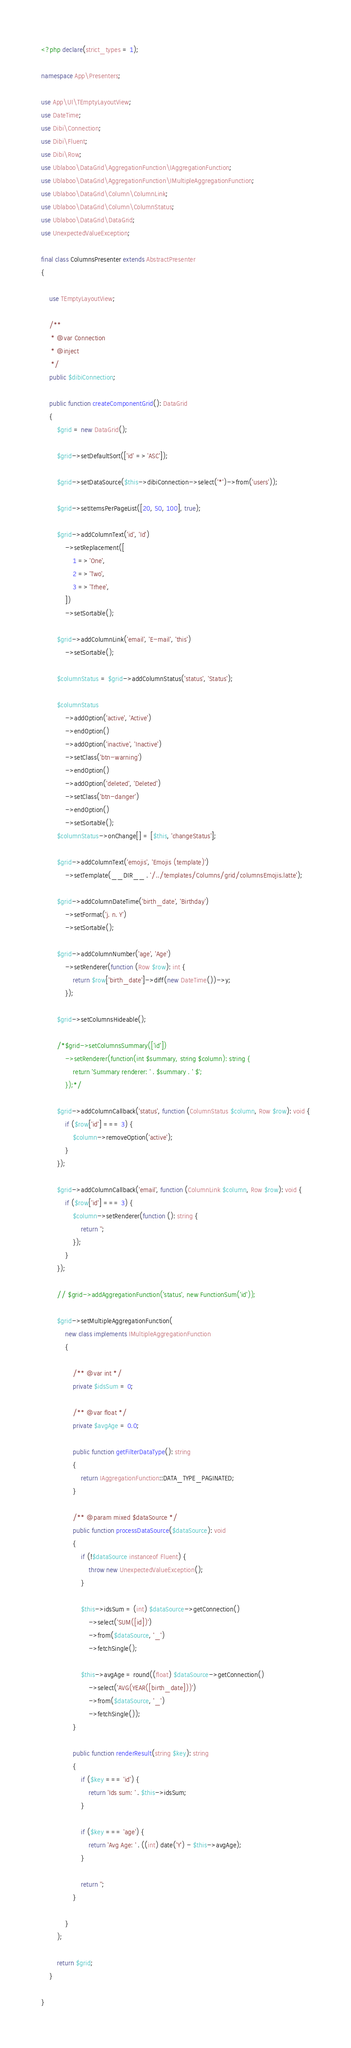Convert code to text. <code><loc_0><loc_0><loc_500><loc_500><_PHP_><?php declare(strict_types = 1);

namespace App\Presenters;

use App\UI\TEmptyLayoutView;
use DateTime;
use Dibi\Connection;
use Dibi\Fluent;
use Dibi\Row;
use Ublaboo\DataGrid\AggregationFunction\IAggregationFunction;
use Ublaboo\DataGrid\AggregationFunction\IMultipleAggregationFunction;
use Ublaboo\DataGrid\Column\ColumnLink;
use Ublaboo\DataGrid\Column\ColumnStatus;
use Ublaboo\DataGrid\DataGrid;
use UnexpectedValueException;

final class ColumnsPresenter extends AbstractPresenter
{

	use TEmptyLayoutView;

	/**
	 * @var Connection
	 * @inject
	 */
	public $dibiConnection;

	public function createComponentGrid(): DataGrid
	{
		$grid = new DataGrid();

		$grid->setDefaultSort(['id' => 'ASC']);

		$grid->setDataSource($this->dibiConnection->select('*')->from('users'));

		$grid->setItemsPerPageList([20, 50, 100], true);

		$grid->addColumnText('id', 'Id')
			->setReplacement([
				1 => 'One',
				2 => 'Two',
				3 => 'Trhee',
			])
			->setSortable();

		$grid->addColumnLink('email', 'E-mail', 'this')
			->setSortable();

		$columnStatus = $grid->addColumnStatus('status', 'Status');

		$columnStatus
			->addOption('active', 'Active')
			->endOption()
			->addOption('inactive', 'Inactive')
			->setClass('btn-warning')
			->endOption()
			->addOption('deleted', 'Deleted')
			->setClass('btn-danger')
			->endOption()
			->setSortable();
		$columnStatus->onChange[] = [$this, 'changeStatus'];

		$grid->addColumnText('emojis', 'Emojis (template)')
			->setTemplate(__DIR__ . '/../templates/Columns/grid/columnsEmojis.latte');

		$grid->addColumnDateTime('birth_date', 'Birthday')
			->setFormat('j. n. Y')
			->setSortable();

		$grid->addColumnNumber('age', 'Age')
			->setRenderer(function (Row $row): int {
				return $row['birth_date']->diff(new DateTime())->y;
			});

		$grid->setColumnsHideable();

		/*$grid->setColumnsSummary(['id'])
			->setRenderer(function(int $summary, string $column): string {
				return 'Summary renderer: ' . $summary . ' $';
			});*/

		$grid->addColumnCallback('status', function (ColumnStatus $column, Row $row): void {
			if ($row['id'] === 3) {
				$column->removeOption('active');
			}
		});

		$grid->addColumnCallback('email', function (ColumnLink $column, Row $row): void {
			if ($row['id'] === 3) {
				$column->setRenderer(function (): string {
					return '';
				});
			}
		});

		// $grid->addAggregationFunction('status', new FunctionSum('id'));

		$grid->setMultipleAggregationFunction(
			new class implements IMultipleAggregationFunction
			{

				/** @var int */
				private $idsSum = 0;

				/** @var float */
				private $avgAge = 0.0;

				public function getFilterDataType(): string
				{
					return IAggregationFunction::DATA_TYPE_PAGINATED;
				}

				/** @param mixed $dataSource */
				public function processDataSource($dataSource): void
				{
					if (!$dataSource instanceof Fluent) {
						throw new UnexpectedValueException();
					}

					$this->idsSum = (int) $dataSource->getConnection()
						->select('SUM([id])')
						->from($dataSource, '_')
						->fetchSingle();

					$this->avgAge = round((float) $dataSource->getConnection()
						->select('AVG(YEAR([birth_date]))')
						->from($dataSource, '_')
						->fetchSingle());
				}

				public function renderResult(string $key): string
				{
					if ($key === 'id') {
						return 'Ids sum: ' . $this->idsSum;
					}

					if ($key === 'age') {
						return 'Avg Age: ' . ((int) date('Y') - $this->avgAge);
					}

					return '';
				}

			}
		);

		return $grid;
	}

}
</code> 